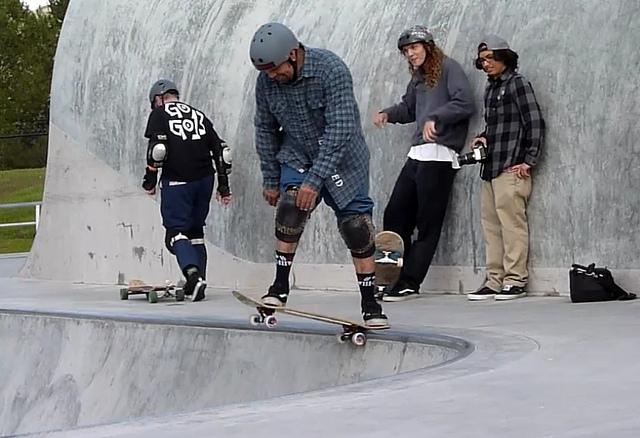Besides his head what part of his body is the skateboarder on the edge of the ramp protecting? Please explain your reasoning. knees. The skateboarder is wearing pads on the body parts he wants to protect and none are on his shoulders, wrists, or elbows. 